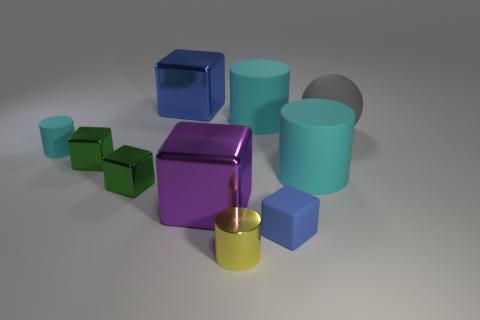How would you categorize the arrangement of these objects? The arrangement appears to be semi-structured with a semblance of symmetry. The objects are placed with a certain deliberateness, suggesting an attempt at an aesthetically pleasing composition rather than random scattering. 